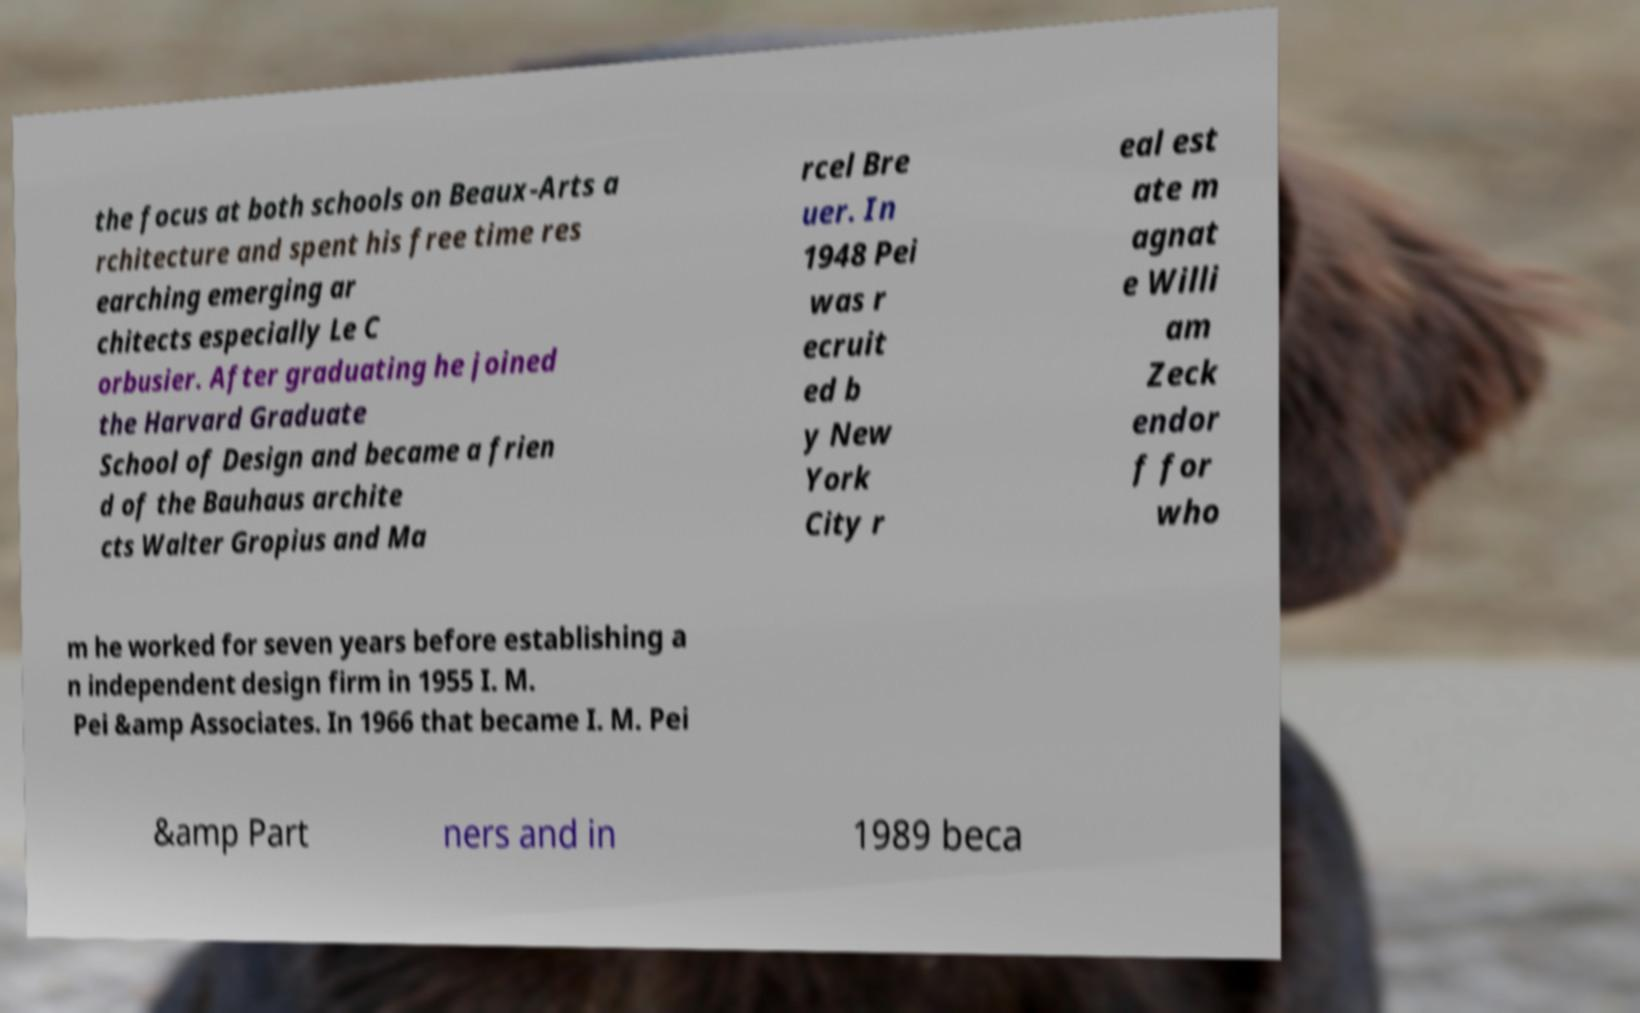For documentation purposes, I need the text within this image transcribed. Could you provide that? the focus at both schools on Beaux-Arts a rchitecture and spent his free time res earching emerging ar chitects especially Le C orbusier. After graduating he joined the Harvard Graduate School of Design and became a frien d of the Bauhaus archite cts Walter Gropius and Ma rcel Bre uer. In 1948 Pei was r ecruit ed b y New York City r eal est ate m agnat e Willi am Zeck endor f for who m he worked for seven years before establishing a n independent design firm in 1955 I. M. Pei &amp Associates. In 1966 that became I. M. Pei &amp Part ners and in 1989 beca 